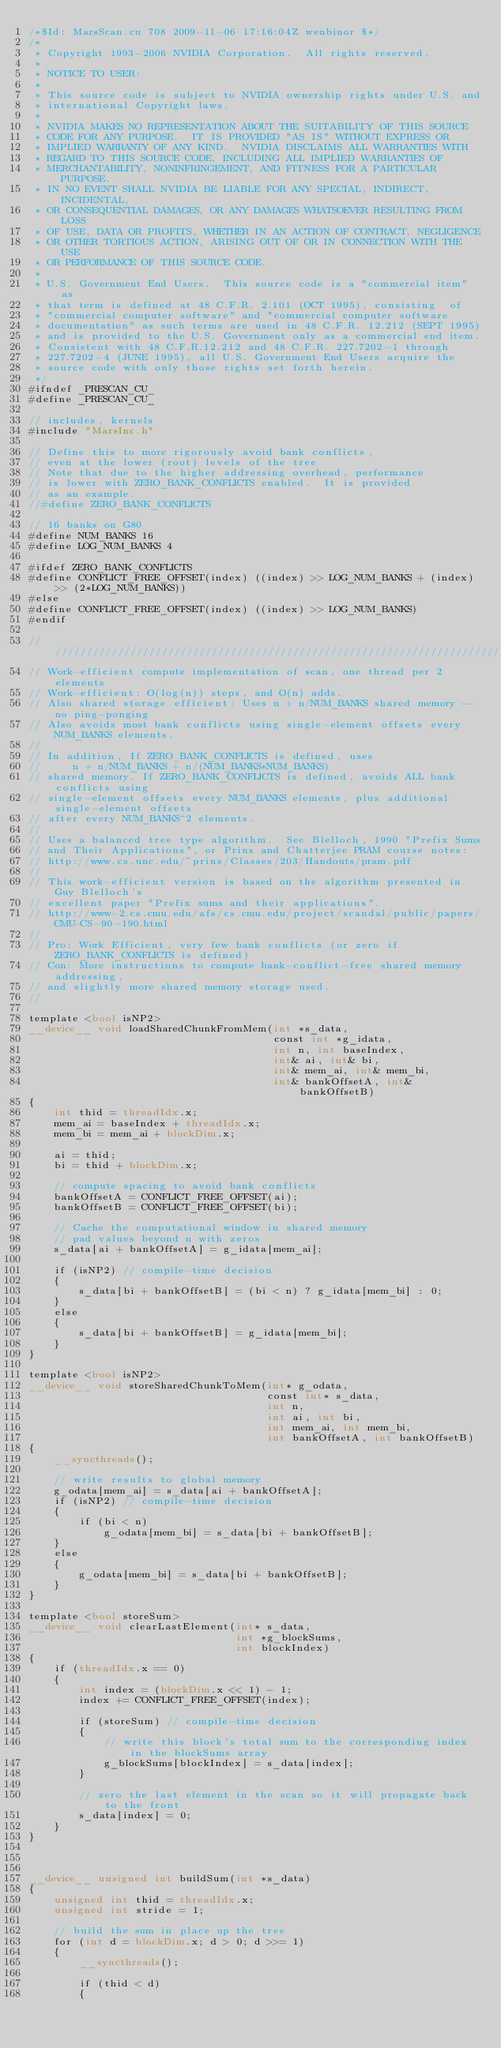<code> <loc_0><loc_0><loc_500><loc_500><_Cuda_>/*$Id: MarsScan.cu 708 2009-11-06 17:16:04Z wenbinor $*/
/*
 * Copyright 1993-2006 NVIDIA Corporation.  All rights reserved.
 *
 * NOTICE TO USER:   
 *
 * This source code is subject to NVIDIA ownership rights under U.S. and 
 * international Copyright laws.  
 *
 * NVIDIA MAKES NO REPRESENTATION ABOUT THE SUITABILITY OF THIS SOURCE 
 * CODE FOR ANY PURPOSE.  IT IS PROVIDED "AS IS" WITHOUT EXPRESS OR 
 * IMPLIED WARRANTY OF ANY KIND.  NVIDIA DISCLAIMS ALL WARRANTIES WITH 
 * REGARD TO THIS SOURCE CODE, INCLUDING ALL IMPLIED WARRANTIES OF 
 * MERCHANTABILITY, NONINFRINGEMENT, AND FITNESS FOR A PARTICULAR PURPOSE.   
 * IN NO EVENT SHALL NVIDIA BE LIABLE FOR ANY SPECIAL, INDIRECT, INCIDENTAL, 
 * OR CONSEQUENTIAL DAMAGES, OR ANY DAMAGES WHATSOEVER RESULTING FROM LOSS 
 * OF USE, DATA OR PROFITS, WHETHER IN AN ACTION OF CONTRACT, NEGLIGENCE 
 * OR OTHER TORTIOUS ACTION, ARISING OUT OF OR IN CONNECTION WITH THE USE 
 * OR PERFORMANCE OF THIS SOURCE CODE.  
 *
 * U.S. Government End Users.  This source code is a "commercial item" as 
 * that term is defined at 48 C.F.R. 2.101 (OCT 1995), consisting  of 
 * "commercial computer software" and "commercial computer software 
 * documentation" as such terms are used in 48 C.F.R. 12.212 (SEPT 1995) 
 * and is provided to the U.S. Government only as a commercial end item.  
 * Consistent with 48 C.F.R.12.212 and 48 C.F.R. 227.7202-1 through 
 * 227.7202-4 (JUNE 1995), all U.S. Government End Users acquire the 
 * source code with only those rights set forth herein.
 */
#ifndef _PRESCAN_CU_
#define _PRESCAN_CU_

// includes, kernels
#include "MarsInc.h"

// Define this to more rigorously avoid bank conflicts, 
// even at the lower (root) levels of the tree
// Note that due to the higher addressing overhead, performance 
// is lower with ZERO_BANK_CONFLICTS enabled.  It is provided
// as an example.
//#define ZERO_BANK_CONFLICTS 

// 16 banks on G80
#define NUM_BANKS 16
#define LOG_NUM_BANKS 4

#ifdef ZERO_BANK_CONFLICTS
#define CONFLICT_FREE_OFFSET(index) ((index) >> LOG_NUM_BANKS + (index) >> (2*LOG_NUM_BANKS))
#else
#define CONFLICT_FREE_OFFSET(index) ((index) >> LOG_NUM_BANKS)
#endif

///////////////////////////////////////////////////////////////////////////////
// Work-efficient compute implementation of scan, one thread per 2 elements
// Work-efficient: O(log(n)) steps, and O(n) adds.
// Also shared storage efficient: Uses n + n/NUM_BANKS shared memory -- no ping-ponging
// Also avoids most bank conflicts using single-element offsets every NUM_BANKS elements.
//
// In addition, If ZERO_BANK_CONFLICTS is defined, uses 
//     n + n/NUM_BANKS + n/(NUM_BANKS*NUM_BANKS) 
// shared memory. If ZERO_BANK_CONFLICTS is defined, avoids ALL bank conflicts using 
// single-element offsets every NUM_BANKS elements, plus additional single-element offsets 
// after every NUM_BANKS^2 elements.
//
// Uses a balanced tree type algorithm.  See Blelloch, 1990 "Prefix Sums 
// and Their Applications", or Prins and Chatterjee PRAM course notes:
// http://www.cs.unc.edu/~prins/Classes/203/Handouts/pram.pdf
// 
// This work-efficient version is based on the algorithm presented in Guy Blelloch's
// excellent paper "Prefix sums and their applications".
// http://www-2.cs.cmu.edu/afs/cs.cmu.edu/project/scandal/public/papers/CMU-CS-90-190.html
//
// Pro: Work Efficient, very few bank conflicts (or zero if ZERO_BANK_CONFLICTS is defined)
// Con: More instructions to compute bank-conflict-free shared memory addressing,
// and slightly more shared memory storage used.
//

template <bool isNP2>
__device__ void loadSharedChunkFromMem(int *s_data,
                                       const int *g_idata, 
                                       int n, int baseIndex,
                                       int& ai, int& bi, 
                                       int& mem_ai, int& mem_bi, 
                                       int& bankOffsetA, int& bankOffsetB)
{
    int thid = threadIdx.x;
    mem_ai = baseIndex + threadIdx.x;
    mem_bi = mem_ai + blockDim.x;

    ai = thid;
    bi = thid + blockDim.x;

    // compute spacing to avoid bank conflicts
    bankOffsetA = CONFLICT_FREE_OFFSET(ai);
    bankOffsetB = CONFLICT_FREE_OFFSET(bi);

    // Cache the computational window in shared memory
    // pad values beyond n with zeros
    s_data[ai + bankOffsetA] = g_idata[mem_ai]; 
    
    if (isNP2) // compile-time decision
    {
        s_data[bi + bankOffsetB] = (bi < n) ? g_idata[mem_bi] : 0; 
    }
    else
    {
        s_data[bi + bankOffsetB] = g_idata[mem_bi]; 
    }
}

template <bool isNP2>
__device__ void storeSharedChunkToMem(int* g_odata, 
                                      const int* s_data,
                                      int n, 
                                      int ai, int bi, 
                                      int mem_ai, int mem_bi,
                                      int bankOffsetA, int bankOffsetB)
{
    __syncthreads();

    // write results to global memory
    g_odata[mem_ai] = s_data[ai + bankOffsetA]; 
    if (isNP2) // compile-time decision
    {
        if (bi < n)
            g_odata[mem_bi] = s_data[bi + bankOffsetB]; 
    }
    else
    {
        g_odata[mem_bi] = s_data[bi + bankOffsetB]; 
    }
}

template <bool storeSum>
__device__ void clearLastElement(int* s_data, 
                                 int *g_blockSums, 
                                 int blockIndex)
{
    if (threadIdx.x == 0)
    {
        int index = (blockDim.x << 1) - 1;
        index += CONFLICT_FREE_OFFSET(index);
        
        if (storeSum) // compile-time decision
        {
            // write this block's total sum to the corresponding index in the blockSums array
            g_blockSums[blockIndex] = s_data[index];
        }

        // zero the last element in the scan so it will propagate back to the front
        s_data[index] = 0;
    }
}



__device__ unsigned int buildSum(int *s_data)
{
    unsigned int thid = threadIdx.x;
    unsigned int stride = 1;
    
    // build the sum in place up the tree
    for (int d = blockDim.x; d > 0; d >>= 1)
    {
        __syncthreads();

        if (thid < d)      
        {</code> 